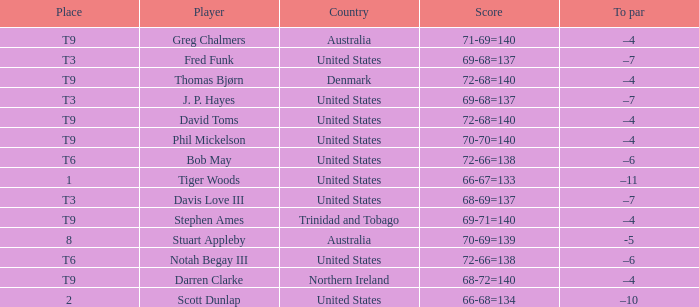What country is Darren Clarke from? Northern Ireland. 